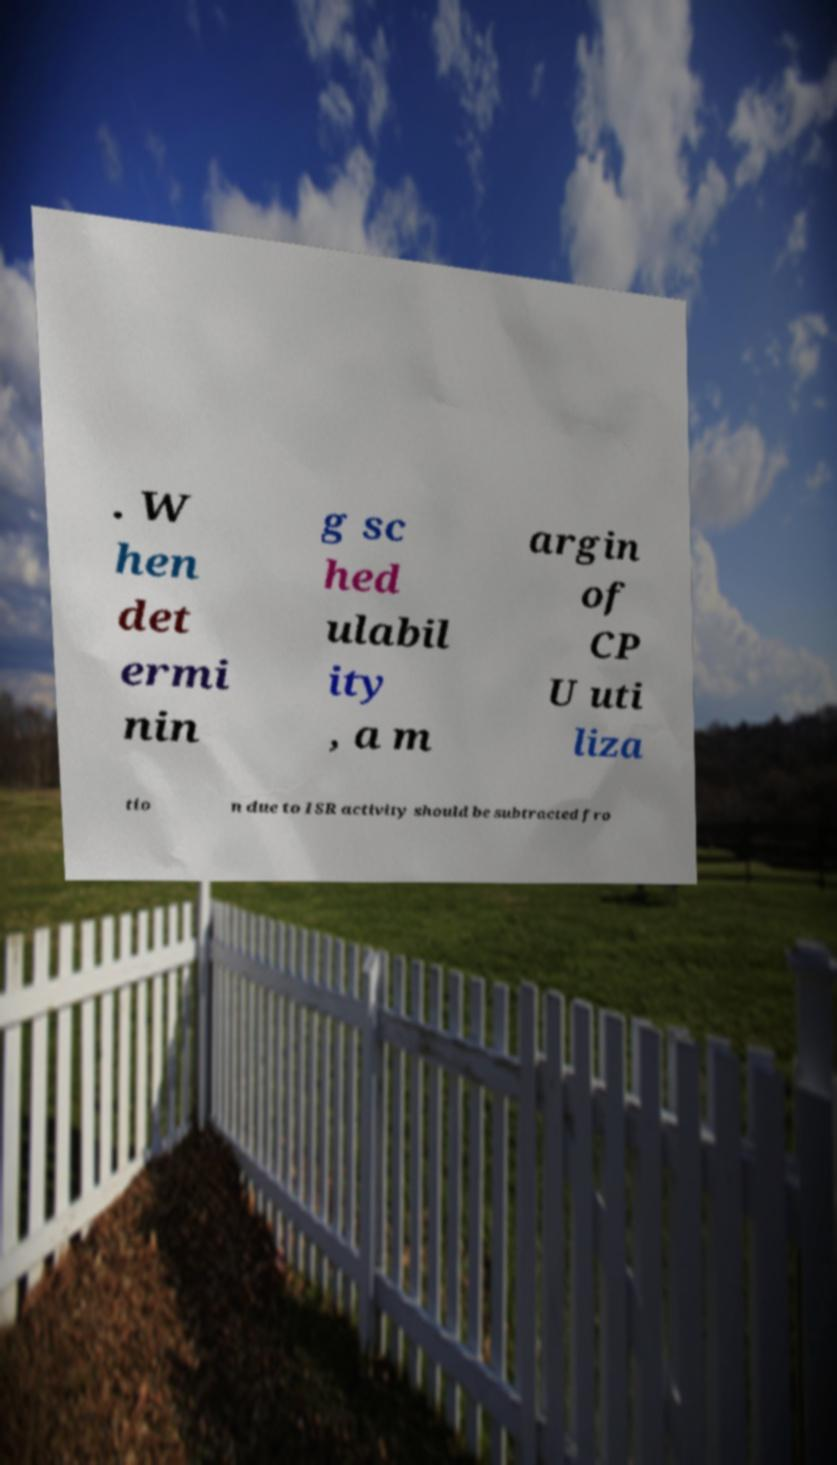Please read and relay the text visible in this image. What does it say? . W hen det ermi nin g sc hed ulabil ity , a m argin of CP U uti liza tio n due to ISR activity should be subtracted fro 